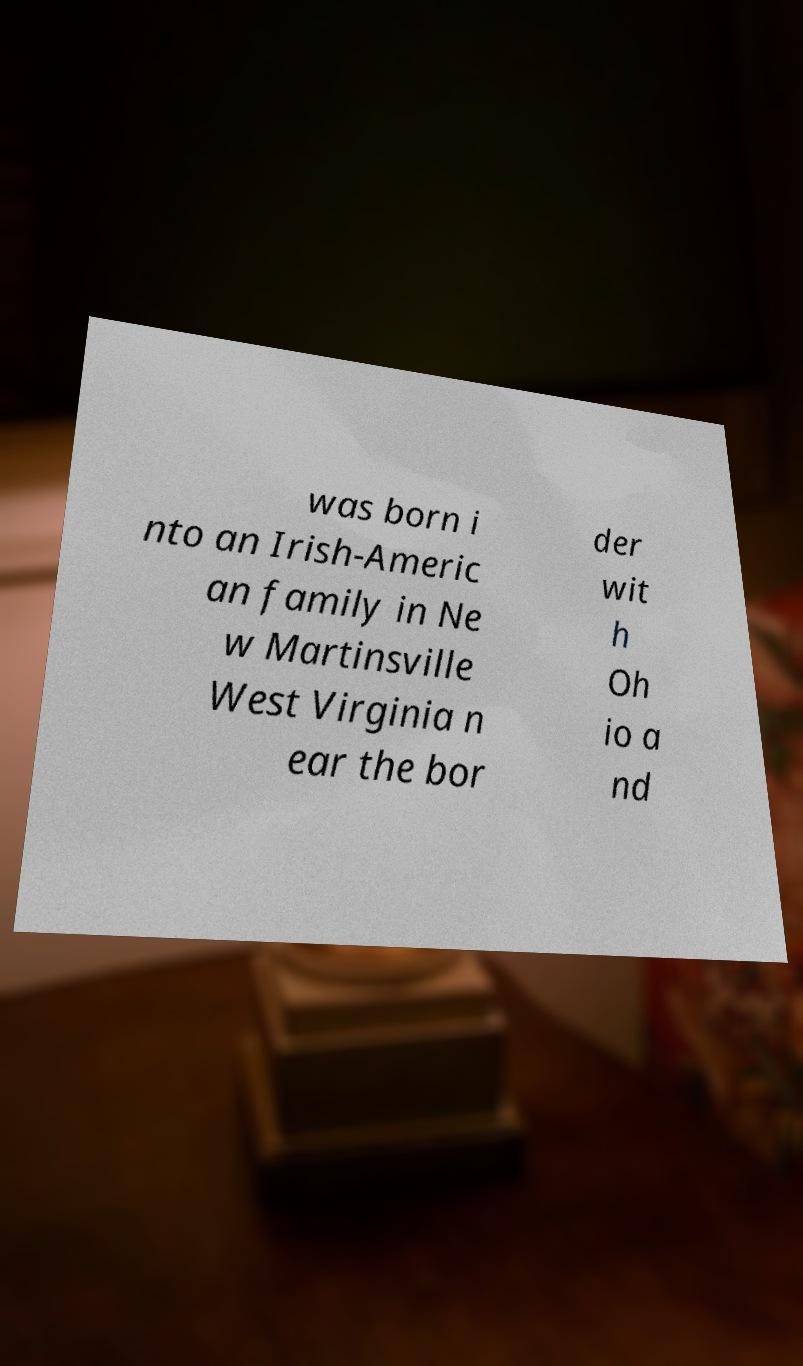Can you read and provide the text displayed in the image?This photo seems to have some interesting text. Can you extract and type it out for me? was born i nto an Irish-Americ an family in Ne w Martinsville West Virginia n ear the bor der wit h Oh io a nd 